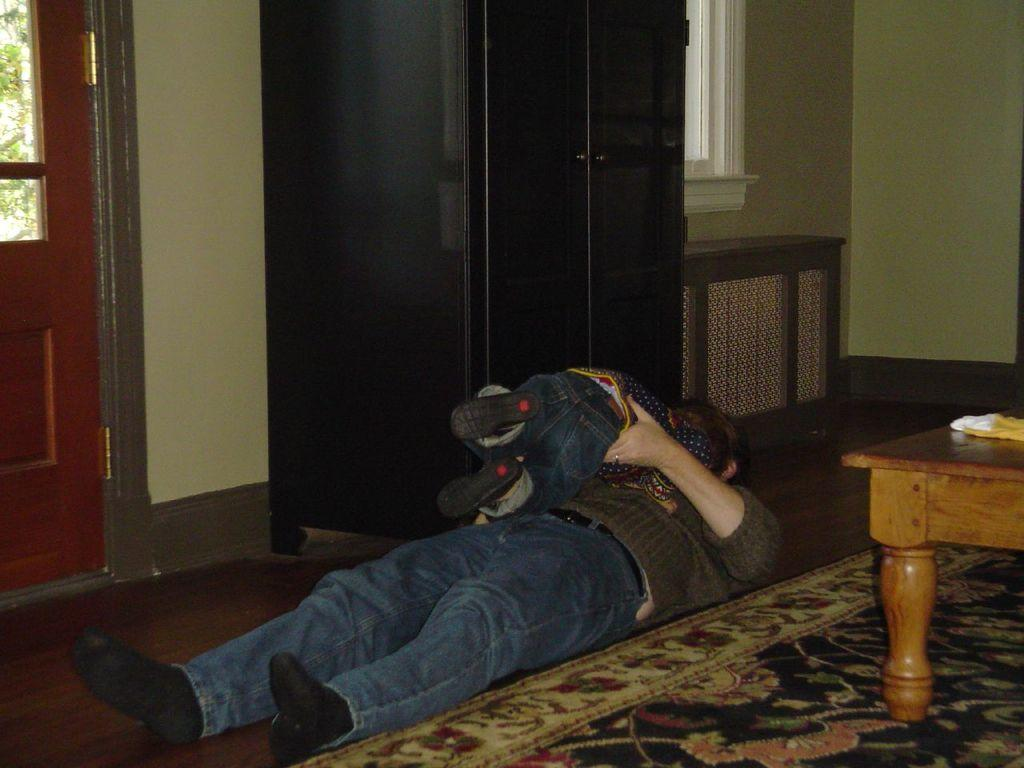Who is present in the image? There is a man and a baby in the image. What are the man and baby doing in the image? Both the man and baby are sleeping. Where are they sleeping in the image? They are sleeping on the floor near a carpet. What can be seen in the background of the image? There is a cupboard, a door, a window, and a table in the background of the image. What type of list is the man holding in the image? There is no list present in the image; the man is sleeping. What color is the dog's hair in the image? There is no dog present in the image, so there is no hair to describe. 